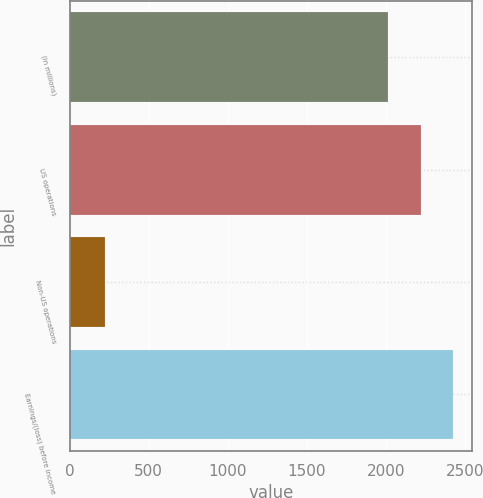Convert chart. <chart><loc_0><loc_0><loc_500><loc_500><bar_chart><fcel>(in millions)<fcel>US operations<fcel>Non-US operations<fcel>Earnings/(loss) before income<nl><fcel>2016<fcel>2221<fcel>226<fcel>2426<nl></chart> 